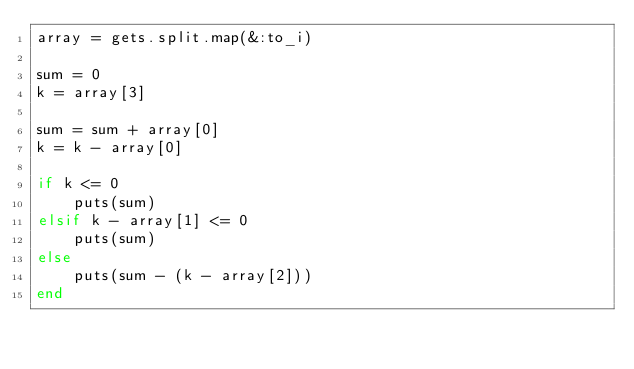<code> <loc_0><loc_0><loc_500><loc_500><_Ruby_>array = gets.split.map(&:to_i)

sum = 0
k = array[3]

sum = sum + array[0]
k = k - array[0]

if k <= 0
    puts(sum)
elsif k - array[1] <= 0
    puts(sum)
else
    puts(sum - (k - array[2]))
end

</code> 